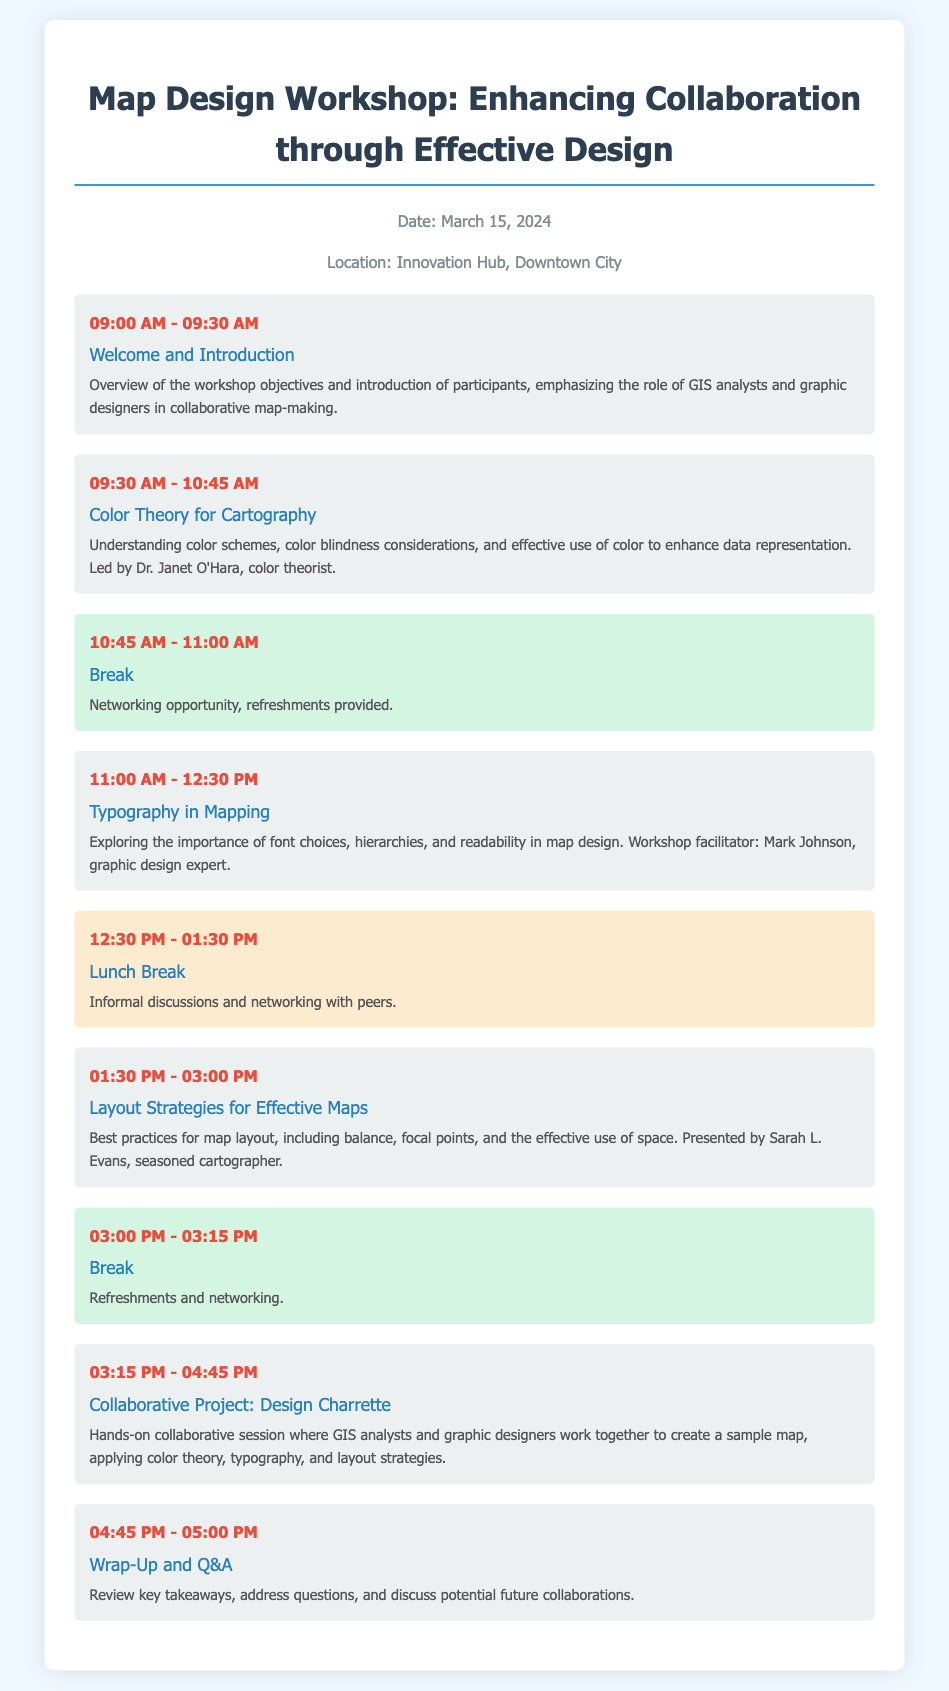What is the date of the workshop? The date of the workshop is provided in the header information of the document.
Answer: March 15, 2024 Who is the facilitator for the Typography in Mapping session? The facilitator's name is mentioned in the description of the Typography session.
Answer: Mark Johnson What time does the Lunch Break start? The start time for the Lunch Break is specified in the schedule.
Answer: 12:30 PM What is the main focus of the session on Color Theory for Cartography? The focus is derived from the description that highlights key elements of the session.
Answer: Color schemes and color blindness considerations How long is the Collaborative Project: Design Charrette session? The duration is calculated based on the start and end time listed in the schedule.
Answer: 1 hour 30 minutes Which session emphasizes the use of space in map design? The session's title and description provide the topic it covers.
Answer: Layout Strategies for Effective Maps What type of session is scheduled after the morning break? The content and context of the sessions guide this classification.
Answer: Typography in Mapping What is the purpose of the Wrap-Up and Q&A session? The key focus of this final session is contained within its description.
Answer: Review key takeaways and address questions 